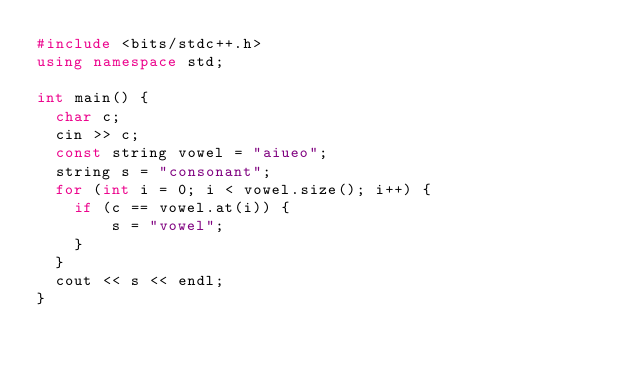Convert code to text. <code><loc_0><loc_0><loc_500><loc_500><_C++_>#include <bits/stdc++.h>
using namespace std;

int main() {
  char c;
  cin >> c;
  const string vowel = "aiueo";
  string s = "consonant";
  for (int i = 0; i < vowel.size(); i++) {
  	if (c == vowel.at(i)) {
    	s = "vowel";
    }
  }
  cout << s << endl;
}</code> 